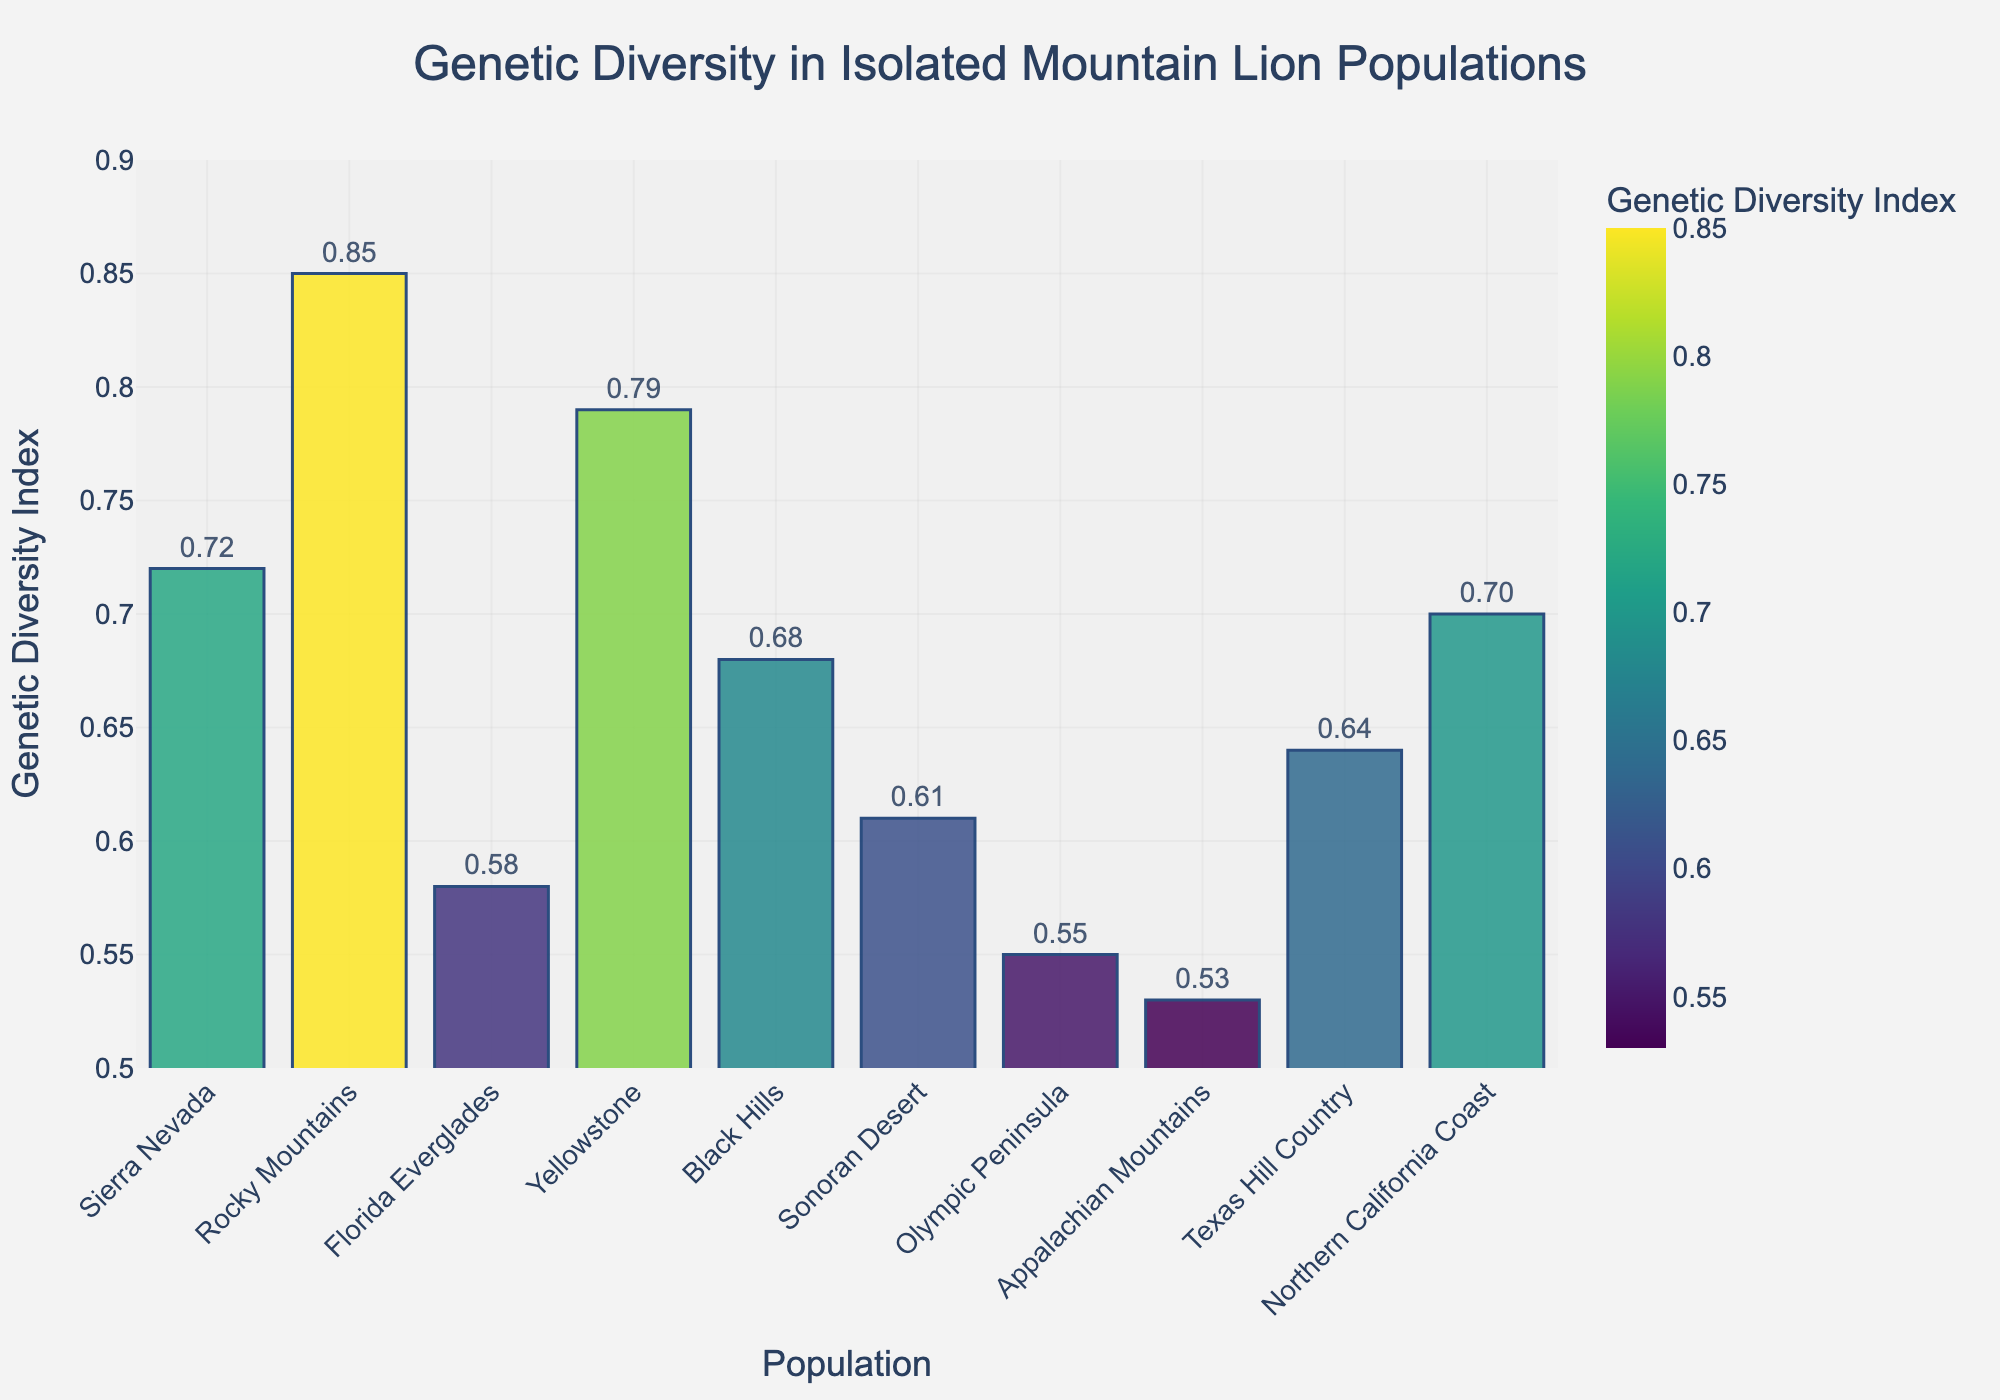Which population has the highest Genetic Diversity Index? Scan all the bars to find the one with the highest value. The Rocky Mountains population has the highest bar, indicating it has the highest Genetic Diversity Index.
Answer: Rocky Mountains Which population has the lowest Genetic Diversity Index? Look for the bar with the least height. The Appalachian Mountains population has the lowest bar, indicating the lowest Genetic Diversity Index.
Answer: Appalachian Mountains What is the average Genetic Diversity Index for all populations? Sum all the Genetic Diversity Index values and divide by the number of populations: (0.72 + 0.85 + 0.58 + 0.79 + 0.68 + 0.61 + 0.55 + 0.53 + 0.64 + 0.70) / 10. Calculation: 6.65 / 10 = 0.665.
Answer: 0.665 How does the Genetic Diversity Index of the Sierra Nevada population compare to that of the Yellowstone population? Compare the heights of the bars representing these populations. The Sierra Nevada bar is slightly shorter than the Yellowstone bar, indicating the Sierra Nevada has a lower Genetic Diversity Index than Yellowstone.
Answer: Lower Which two populations have the closest Genetic Diversity Index values? Look for bars that have similar heights. The populations of Sierra Nevada (0.72) and Northern California Coast (0.70) have very close Genetic Diversity Index values.
Answer: Sierra Nevada and Northern California Coast What is the total Genetic Diversity Index for all populations combined? Sum all the Genetic Diversity Index values: 0.72 + 0.85 + 0.58 + 0.79 + 0.68 + 0.61 + 0.55 + 0.53 + 0.64 + 0.70 = 6.65.
Answer: 6.65 Which population is the second highest in Genetic Diversity Index? Identify the highest value first, which is the Rocky Mountains (0.85), and then find the next highest value, which is Yellowstone (0.79).
Answer: Yellowstone For which population does the Genetic Diversity Index fall between 0.6 and 0.7? Scan the bars with the range of heights falling between 0.6 and 0.7. The populations that fall within this range are Sonoran Desert (0.61), Texas Hill Country (0.64), and Northern California Coast (0.70).
Answer: Sonoran Desert, Texas Hill Country, and Northern California Coast By how much does the Genetic Diversity Index of the Florida Everglades population differ from that of the Black Hills population? Subtract the Genetic Diversity Index of the two populations: 0.68 (Black Hills) - 0.58 (Florida Everglades) = 0.10.
Answer: 0.10 Which population has a Genetic Diversity Index closest to the average Genetic Diversity Index? First, calculate the average (0.665) and then compare it with the bars. The population with the Genetic Diversity Index closest to this average is Texas Hill Country (0.64) and Northern California Coast (0.70).
Answer: Texas Hill Country and Northern California Coast 